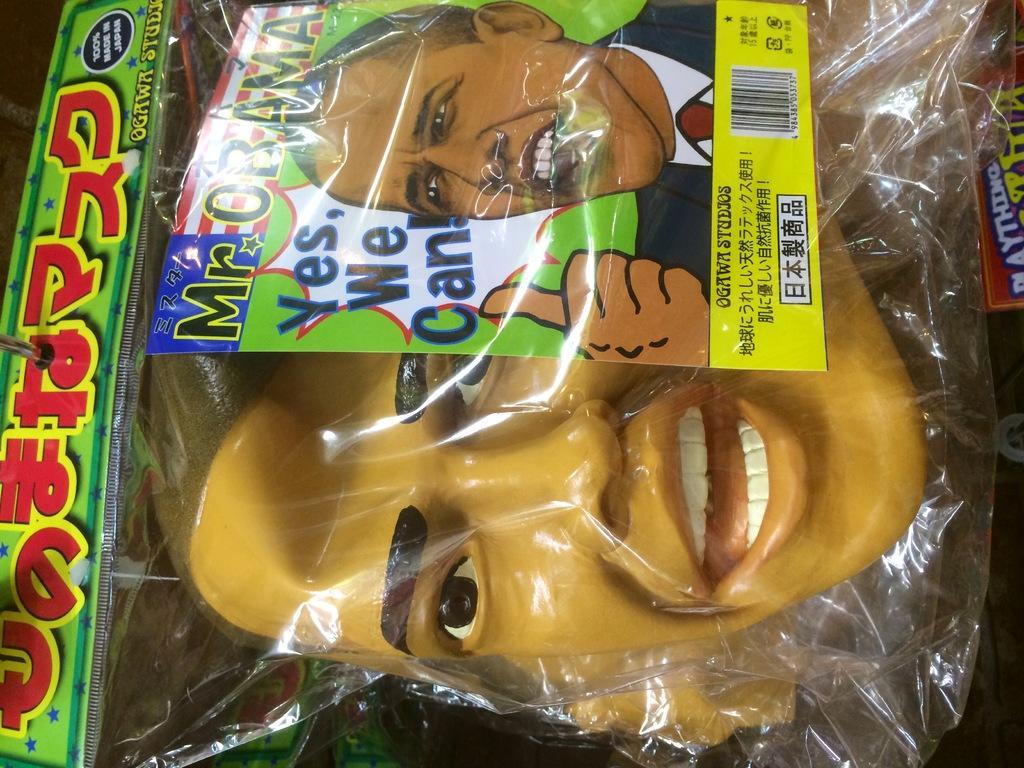How would you summarize this image in a sentence or two? In this image there is a face mask inside a cover. 